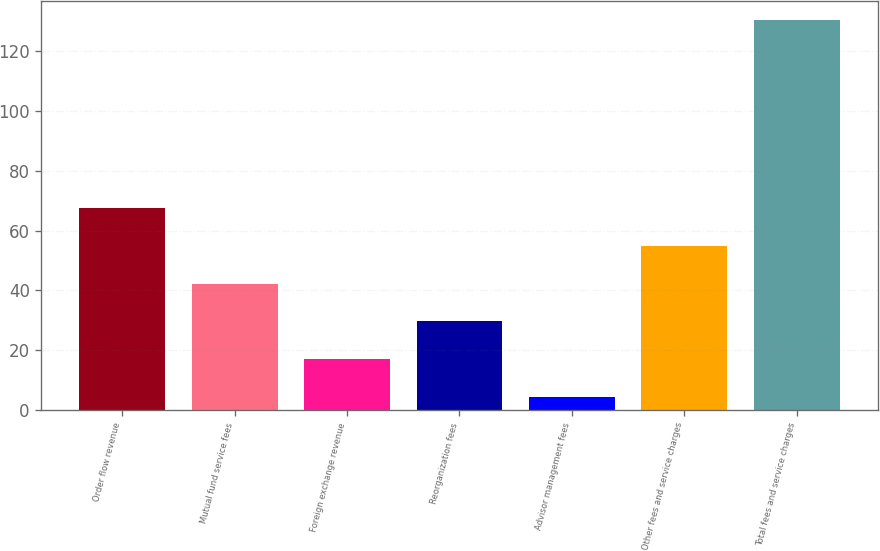Convert chart. <chart><loc_0><loc_0><loc_500><loc_500><bar_chart><fcel>Order flow revenue<fcel>Mutual fund service fees<fcel>Foreign exchange revenue<fcel>Reorganization fees<fcel>Advisor management fees<fcel>Other fees and service charges<fcel>Total fees and service charges<nl><fcel>67.4<fcel>42.2<fcel>17<fcel>29.6<fcel>4.4<fcel>54.8<fcel>130.4<nl></chart> 